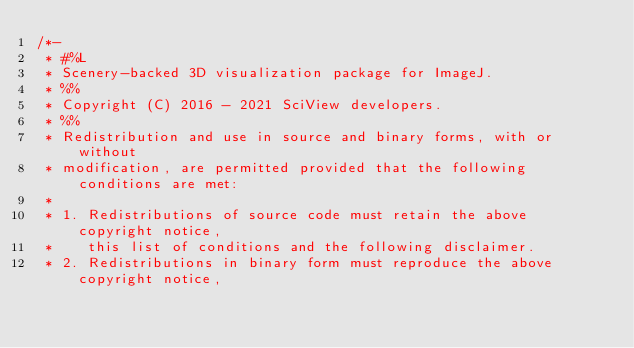Convert code to text. <code><loc_0><loc_0><loc_500><loc_500><_Java_>/*-
 * #%L
 * Scenery-backed 3D visualization package for ImageJ.
 * %%
 * Copyright (C) 2016 - 2021 SciView developers.
 * %%
 * Redistribution and use in source and binary forms, with or without
 * modification, are permitted provided that the following conditions are met:
 * 
 * 1. Redistributions of source code must retain the above copyright notice,
 *    this list of conditions and the following disclaimer.
 * 2. Redistributions in binary form must reproduce the above copyright notice,</code> 